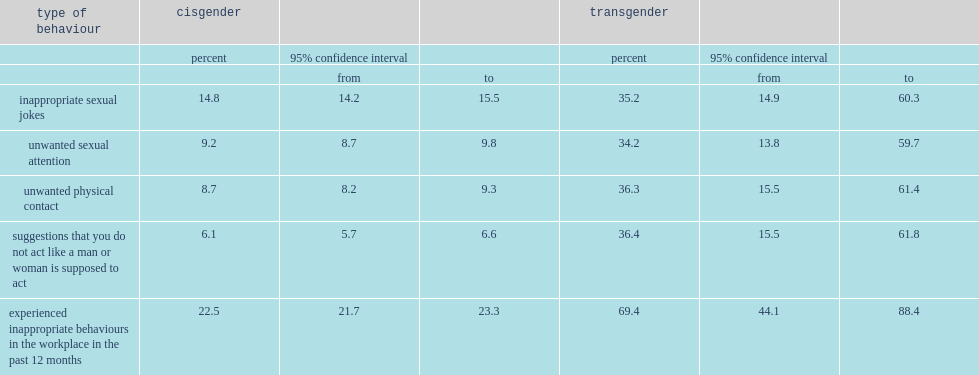Would you be able to parse every entry in this table? {'header': ['type of behaviour', 'cisgender', '', '', 'transgender', '', ''], 'rows': [['', 'percent', '95% confidence interval', '', 'percent', '95% confidence interval', ''], ['', '', 'from', 'to', '', 'from', 'to'], ['inappropriate sexual jokes', '14.8', '14.2', '15.5', '35.2', '14.9', '60.3'], ['unwanted sexual attention', '9.2', '8.7', '9.8', '34.2', '13.8', '59.7'], ['unwanted physical contact', '8.7', '8.2', '9.3', '36.3', '15.5', '61.4'], ['suggestions that you do not act like a man or woman is supposed to act', '6.1', '5.7', '6.6', '36.4', '15.5', '61.8'], ['experienced inappropriate behaviours in the workplace in the past 12 months', '22.5', '21.7', '23.3', '69.4', '44.1', '88.4']]} Which group of people were more likely to experience unwanted physical contact and suggestions that they do not act like a man or woman is supposed to act while at work? transgender canadians or cisgender canadians? Transgender. 